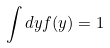Convert formula to latex. <formula><loc_0><loc_0><loc_500><loc_500>\int d y f ( y ) = 1</formula> 